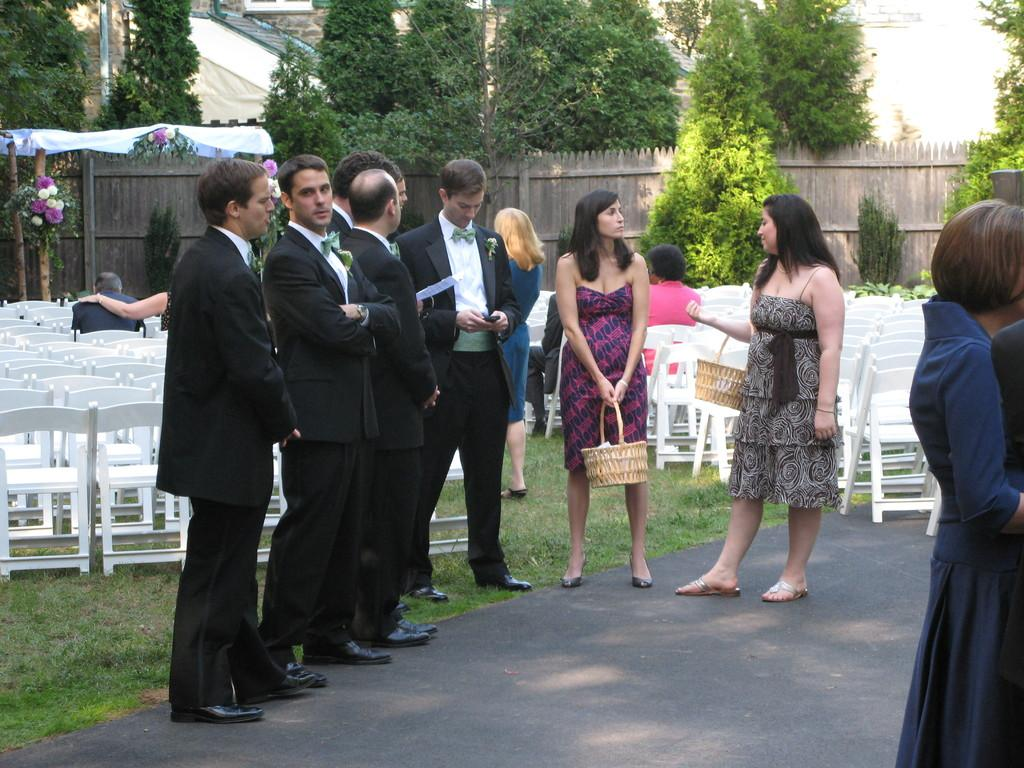What are the people in the image doing? The persons in the image are standing on the road. What type of vegetation can be seen in the image? There is grass, plants, trees, and flowers visible in the image. What type of furniture is present in the image? There are chairs in the image. What type of barrier is present in the image? There is a fence in the image. What type of light is hanging from the shelf in the image? There is no shelf or light present in the image. 